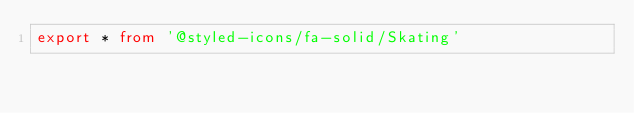Convert code to text. <code><loc_0><loc_0><loc_500><loc_500><_TypeScript_>export * from '@styled-icons/fa-solid/Skating'</code> 